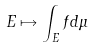Convert formula to latex. <formula><loc_0><loc_0><loc_500><loc_500>E \mapsto \int _ { E } f d \mu</formula> 